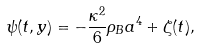Convert formula to latex. <formula><loc_0><loc_0><loc_500><loc_500>\psi ( t , y ) = - \frac { \kappa ^ { 2 } } { 6 } \rho _ { B } a ^ { 4 } + \zeta ( t ) ,</formula> 